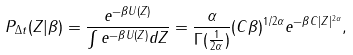Convert formula to latex. <formula><loc_0><loc_0><loc_500><loc_500>P _ { \Delta t } ( Z | \beta ) = \frac { e ^ { - \beta U ( Z ) } } { \int e ^ { - \beta U ( Z ) } d Z } = \frac { \alpha } { \Gamma ( \frac { 1 } { 2 \alpha } ) } ( C \beta ) ^ { 1 / 2 \alpha } e ^ { - \beta C | Z | ^ { 2 \alpha } } ,</formula> 